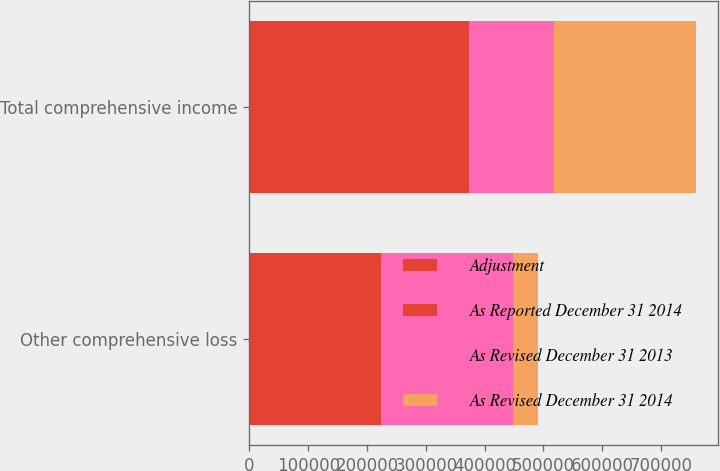Convert chart to OTSL. <chart><loc_0><loc_0><loc_500><loc_500><stacked_bar_chart><ecel><fcel>Other comprehensive loss<fcel>Total comprehensive income<nl><fcel>Adjustment<fcel>109507<fcel>259200<nl><fcel>As Reported December 31 2014<fcel>114184<fcel>114184<nl><fcel>As Revised December 31 2013<fcel>223691<fcel>145016<nl><fcel>As Revised December 31 2014<fcel>44080<fcel>240421<nl></chart> 